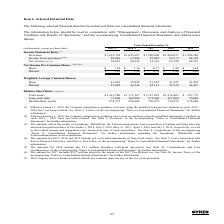From Sykes Enterprises Incorporated's financial document, In which years was the Income Statement Data provided for The document contains multiple relevant values: 2019, 2018, 2017, 2016, 2015. From the document: "(in thousands, except per share data) 2019 (1) 2018 (2) 2017 2016 2015 (in thousands, except per share data) 2019 (1) 2018 (2) 2017 2016 2015 ds, exce..." Also, What is the basic net income per common share in 2019? According to the financial document, $1.54. The relevant text states: "Basic $ 1.54 $ 1.16 $ 0.77 $ 1.49 $ 1.64..." Also, For which items in the table does the amount for 2017 includes the sum related to the impact of the 2017 Tax Reform Act? The document contains multiple relevant values: Net income, Net Income Per Common Share, Balance Sheet Data. From the document: "Net Income Per Common Share: (3)(4)(5)(6) Net Income Per Common Share: (3)(4)(5)(6) Balance Sheet Data: (3)(4)(6)(7)..." Additionally, In which year was the Diluted Net Income per Common Share largest? According to the financial document, 2015. The relevant text states: "xcept per share data) 2019 (1) 2018 (2) 2017 2016 2015..." Also, can you calculate: What was the change in the basic net income per common share in 2019 from 2018? Based on the calculation: 1.54-1.16, the result is 0.38. This is based on the information: "Basic $ 1.54 $ 1.16 $ 0.77 $ 1.49 $ 1.64 Basic $ 1.54 $ 1.16 $ 0.77 $ 1.49 $ 1.64..." The key data points involved are: 1.16, 1.54. Also, can you calculate: What was the percentage change in the basic net income per common share in 2019 from 2018? To answer this question, I need to perform calculations using the financial data. The calculation is: (1.54-1.16)/1.16, which equals 32.76 (percentage). This is based on the information: "Basic $ 1.54 $ 1.16 $ 0.77 $ 1.49 $ 1.64 Basic $ 1.54 $ 1.16 $ 0.77 $ 1.49 $ 1.64..." The key data points involved are: 1.16, 1.54. 